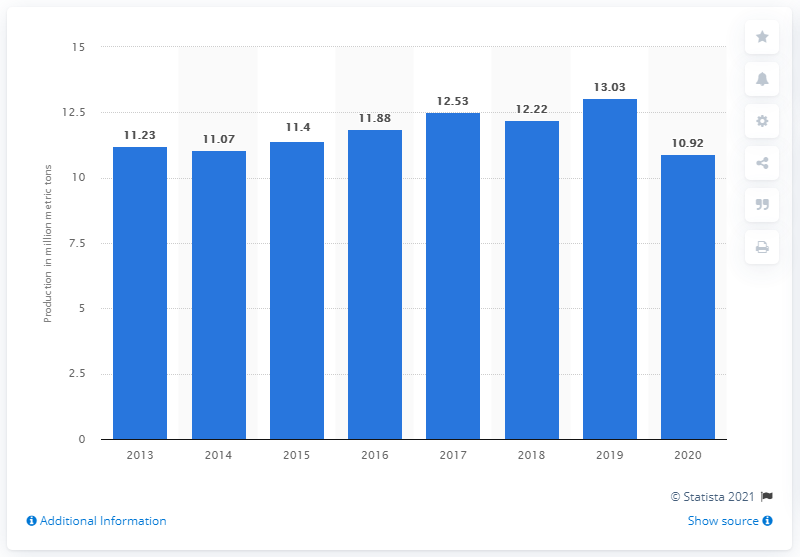Mention a couple of crucial points in this snapshot. In 2020, a total of 10.92 million metric tons of diesel and gas oil were produced in Malaysia. 